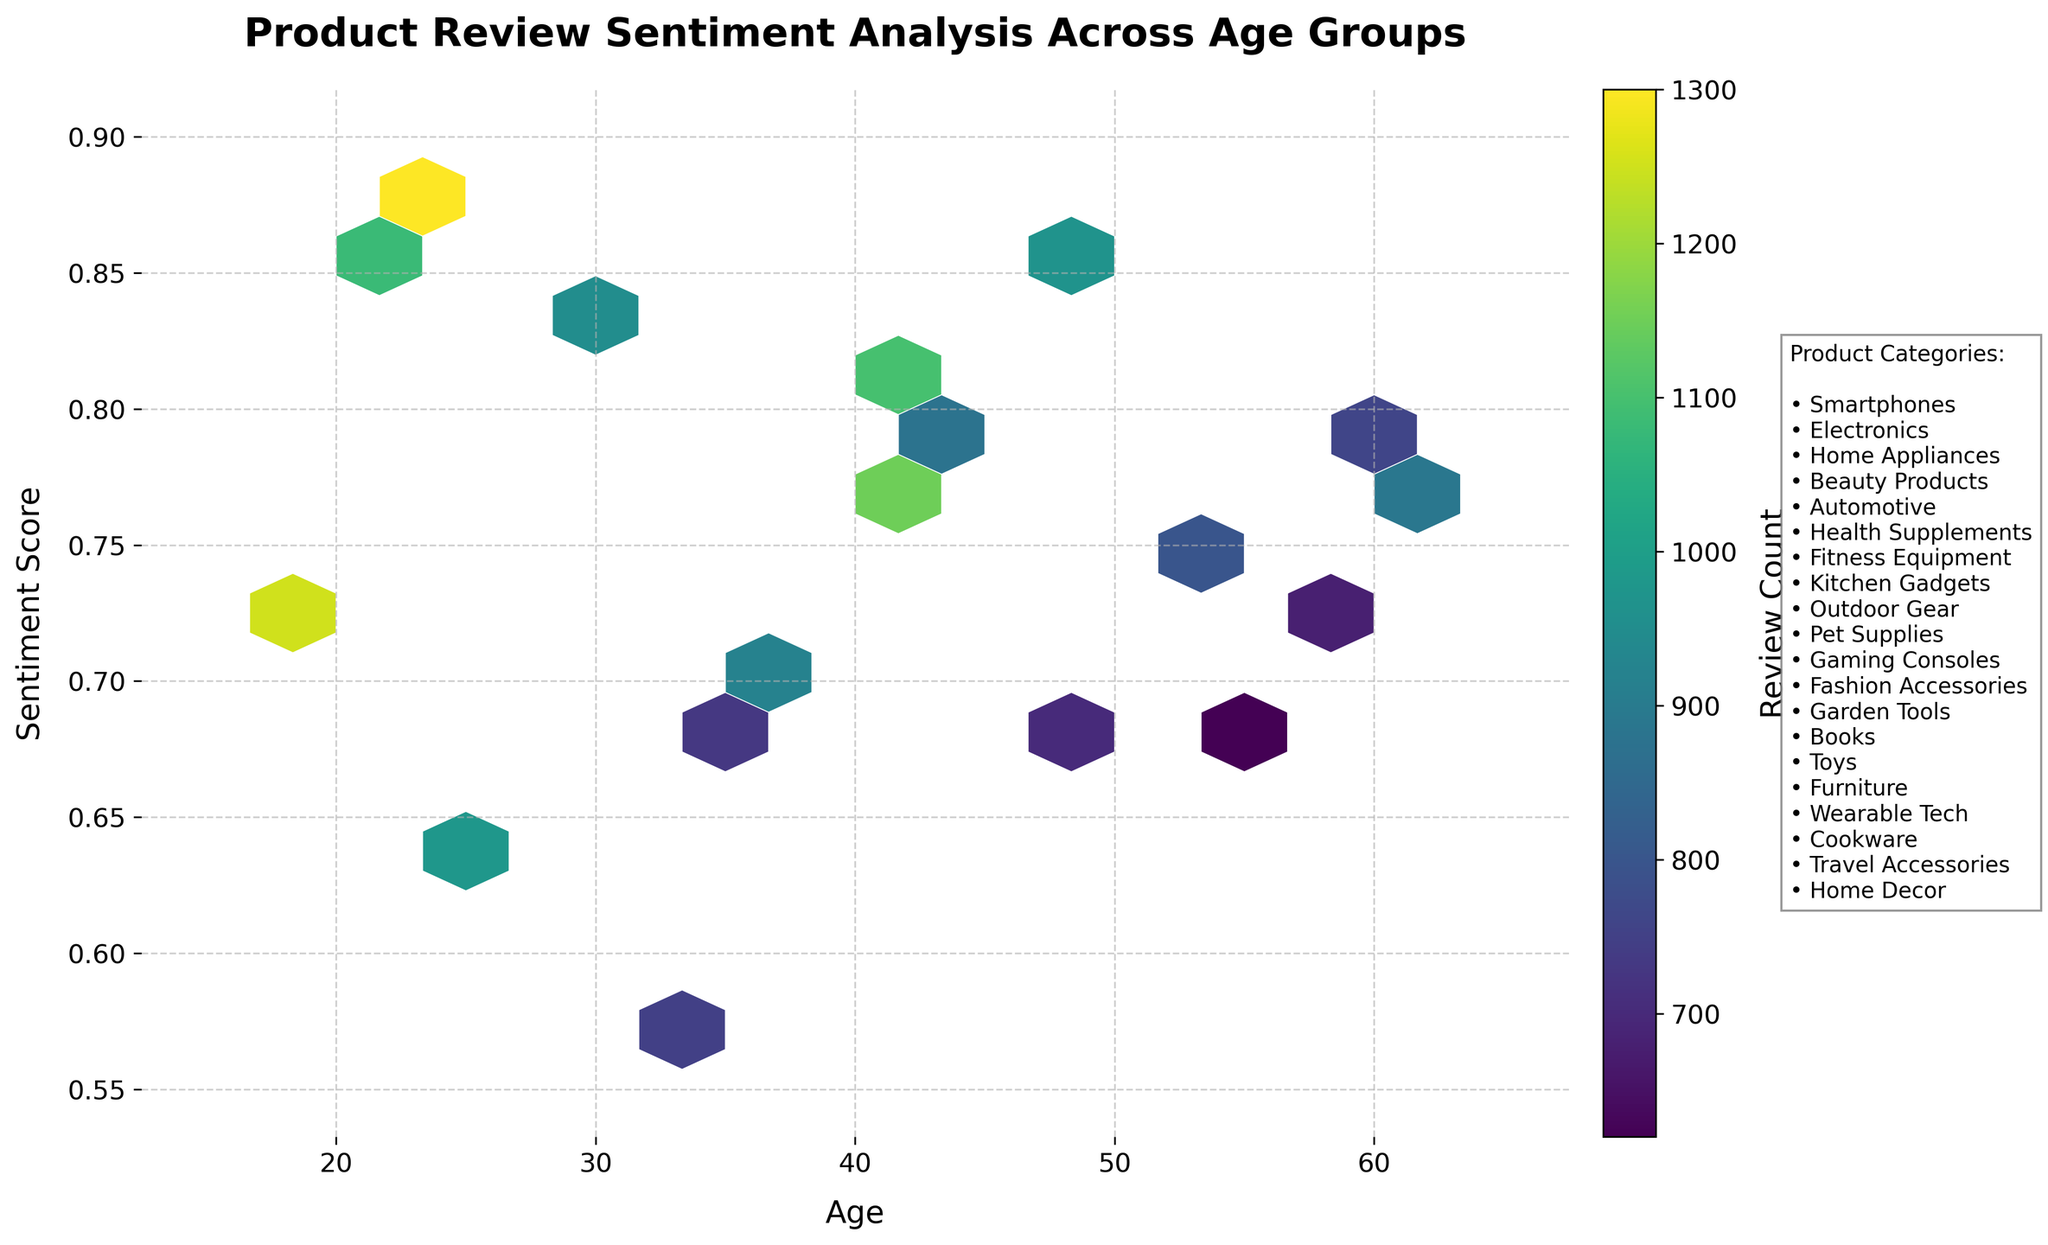What is the title of the figure? The title is displayed at the top of the figure in a prominent font to help identify the main subject of the plot.
Answer: Product Review Sentiment Analysis Across Age Groups What does the color intensity represent in this hexbin plot? In hexbin plots, color intensity usually represents the count of data points within each hexagon. The more intense the color, the higher the count. This information is also specified by the color bar next to the plot.
Answer: Review Count Which age group has the highest sentiment score for any product category? By examining the plot, look for the highest y-axis value within the scatter of hexagons. Identify the corresponding age from the x-axis below this hexagon.
Answer: 22 What is the range of sentiment scores on this plot? The y-axis denotes sentiment scores. By examining the minimum and maximum y-axis values, we can determine this range.
Answer: 0.55 to 0.9 How does the sentiment score for age 50 compare to age 55? Locate both ages on the x-axis and observe their corresponding sentiment scores on the y-axis. Compare the two values visually by noting their placements on the y-axis.
Answer: Age 50 has a higher sentiment score than age 55 Is there an age group with consistently high sentiment scores across multiple product categories? Look across the figure horizontally at the dispersal of hexagons to see if any particular age groups have multiple hexagons with high sentiment scores (closer to 0.85 - 0.9). This would indicate consistently high sentiment in those age ranges.
Answer: No, there is no specific age group with consistently high sentiment scores across multiple categories Which product category text is located at the very bottom of the categorized text box? The categorized text is located to the side of the plot, list all categories descending. Identify the last product listed.
Answer: Home Decor How diverse is the range of sentiment scores for age 40 compared to age 60? Identify all hexagons containing these ages. Note the spread of their y-values (sentiment scores) to compare their diversity. Age 40 has values around 0.81, whereas age 60 has slightly lower values, but ranges must be directly compared.
Answer: Age 40 is slightly more diverse in sentiment scores than age 60 Categorize sentiment scores for the youngest and oldest age groups in the plot. Locate the youngest and oldest ages (18 and 62) on the x-axis and note their corresponding sentiment scores on the y-axis.
Answer: Age 18: 0.72, Age 62: 0.76 